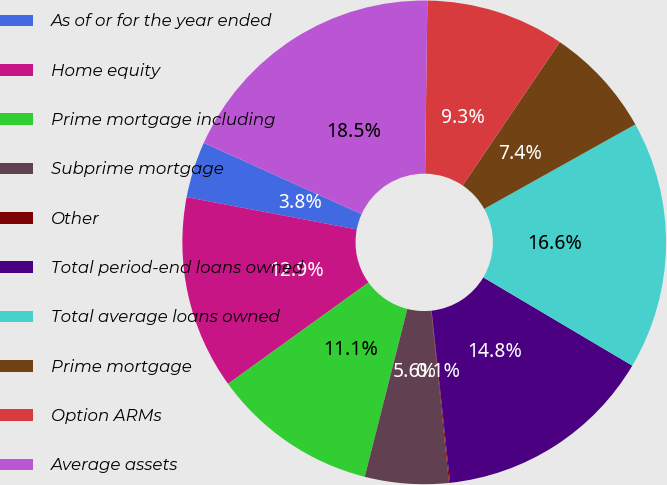Convert chart to OTSL. <chart><loc_0><loc_0><loc_500><loc_500><pie_chart><fcel>As of or for the year ended<fcel>Home equity<fcel>Prime mortgage including<fcel>Subprime mortgage<fcel>Other<fcel>Total period-end loans owned<fcel>Total average loans owned<fcel>Prime mortgage<fcel>Option ARMs<fcel>Average assets<nl><fcel>3.75%<fcel>12.94%<fcel>11.1%<fcel>5.59%<fcel>0.07%<fcel>14.78%<fcel>16.62%<fcel>7.42%<fcel>9.26%<fcel>18.46%<nl></chart> 